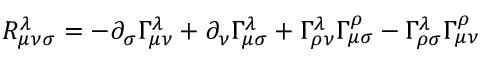Convert formula to latex. <formula><loc_0><loc_0><loc_500><loc_500>R _ { \mu \nu \sigma } ^ { \lambda } = - \partial _ { \sigma } \Gamma _ { \mu \nu } ^ { \lambda } + \partial _ { \nu } \Gamma _ { \mu \sigma } ^ { \lambda } + \Gamma _ { \rho \nu } ^ { \lambda } \Gamma _ { \mu \sigma } ^ { \rho } - \Gamma _ { \rho \sigma } ^ { \lambda } \Gamma _ { \mu \nu } ^ { \rho }</formula> 